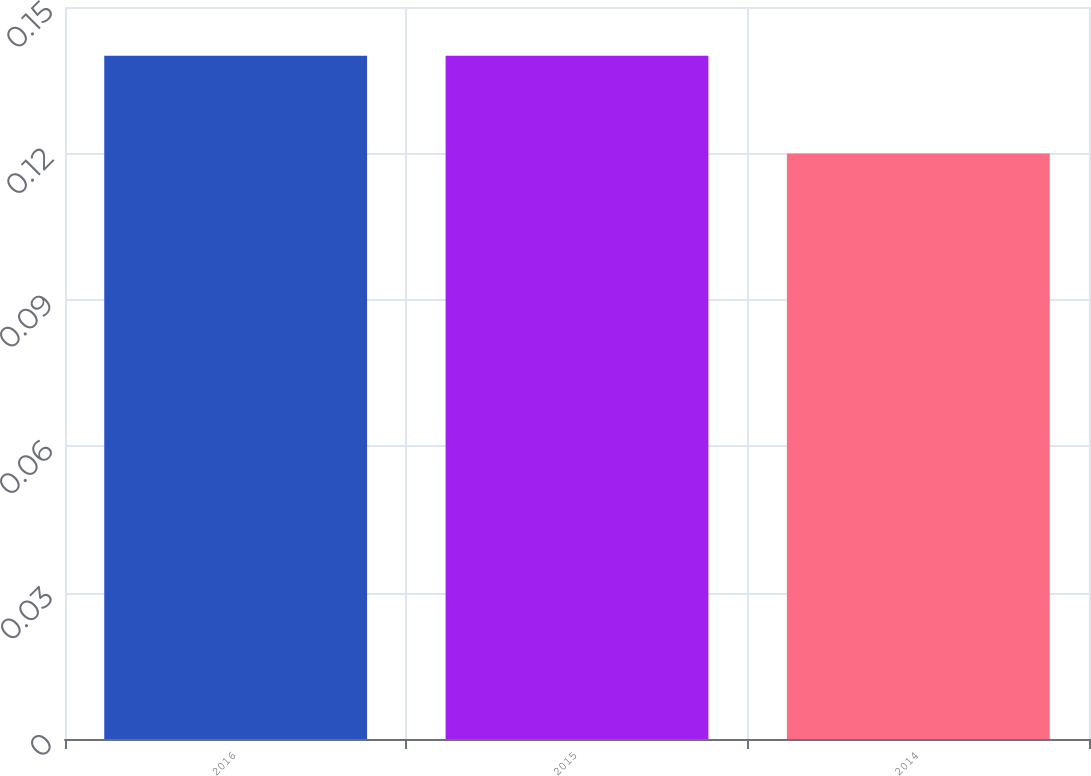<chart> <loc_0><loc_0><loc_500><loc_500><bar_chart><fcel>2016<fcel>2015<fcel>2014<nl><fcel>0.14<fcel>0.14<fcel>0.12<nl></chart> 